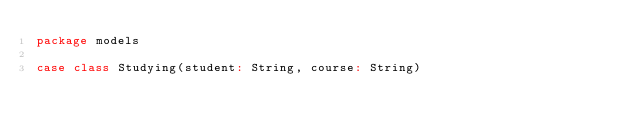Convert code to text. <code><loc_0><loc_0><loc_500><loc_500><_Scala_>package models

case class Studying(student: String, course: String)
</code> 